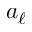<formula> <loc_0><loc_0><loc_500><loc_500>a _ { \ell }</formula> 